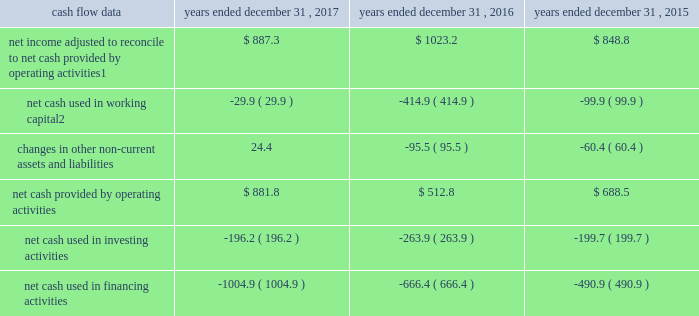Management 2019s discussion and analysis of financial condition and results of operations 2013 ( continued ) ( amounts in millions , except per share amounts ) operating income increased during 2017 when compared to 2016 , comprised of a decrease in revenue of $ 42.1 , as discussed above , a decrease in salaries and related expenses of $ 28.0 and a decrease in office and general expenses of $ 16.9 .
The decrease in salaries and related expenses was primarily due to lower discretionary bonuses and incentive expense as well as a decrease in base salaries , benefits and tax .
The decrease in office and general expenses was primarily due to decreases in adjustments to contingent acquisition obligations , as compared to the prior year .
Operating income increased during 2016 when compared to 2015 due to an increase in revenue of $ 58.8 , as discussed above , and a decrease in office and general expenses of $ 3.7 , partially offset by an increase in salaries and related expenses of $ 38.8 .
The increase in salaries and related expenses was attributable to an increase in base salaries , benefits and tax primarily due to increases in our workforce to support business growth over the last twelve months .
The decrease in office and general expenses was primarily due to lower production expenses related to pass-through costs , which are also reflected in revenue , for certain projects in which we acted as principal that decreased in size or did not recur during the current year .
Corporate and other certain corporate and other charges are reported as a separate line item within total segment operating income and include corporate office expenses , as well as shared service center and certain other centrally managed expenses that are not fully allocated to operating divisions .
Salaries and related expenses include salaries , long-term incentives , annual bonuses and other miscellaneous benefits for corporate office employees .
Office and general expenses primarily include professional fees related to internal control compliance , financial statement audits and legal , information technology and other consulting services that are engaged and managed through the corporate office .
Office and general expenses also include rental expense and depreciation of leasehold improvements for properties occupied by corporate office employees .
A portion of centrally managed expenses are allocated to operating divisions based on a formula that uses the planned revenues of each of the operating units .
Amounts allocated also include specific charges for information technology-related projects , which are allocated based on utilization .
Corporate and other expenses decreased during 2017 by $ 20.6 to $ 126.6 compared to 2016 , primarily due to lower annual incentive expense .
Corporate and other expenses increased during 2016 by $ 5.4 to $ 147.2 compared to 2015 .
Liquidity and capital resources cash flow overview the tables summarize key financial data relating to our liquidity , capital resources and uses of capital. .
1 reflects net income adjusted primarily for depreciation and amortization of fixed assets and intangible assets , amortization of restricted stock and other non-cash compensation , net losses on sales of businesses and deferred income taxes .
2 reflects changes in accounts receivable , expenditures billable to clients , other current assets , accounts payable and accrued liabilities .
Operating activities due to the seasonality of our business , we typically use cash from working capital in the first nine months of a year , with the largest impact in the first quarter , and generate cash from working capital in the fourth quarter , driven by the seasonally strong media spending by our clients .
Quarterly and annual working capital results are impacted by the fluctuating annual media spending budgets of our clients as well as their changing media spending patterns throughout each year across various countries. .
What is the net change in cash for 2017? 
Computations: ((881.8 + -196.2) + -1004.9)
Answer: -319.3. 